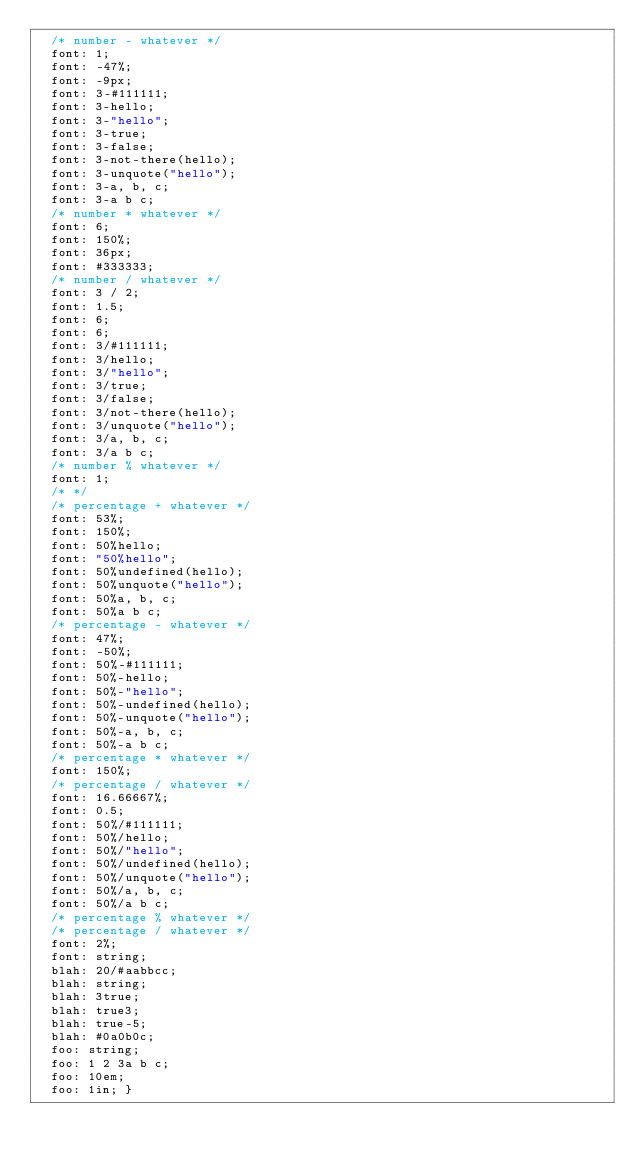Convert code to text. <code><loc_0><loc_0><loc_500><loc_500><_CSS_>  /* number - whatever */
  font: 1;
  font: -47%;
  font: -9px;
  font: 3-#111111;
  font: 3-hello;
  font: 3-"hello";
  font: 3-true;
  font: 3-false;
  font: 3-not-there(hello);
  font: 3-unquote("hello");
  font: 3-a, b, c;
  font: 3-a b c;
  /* number * whatever */
  font: 6;
  font: 150%;
  font: 36px;
  font: #333333;
  /* number / whatever */
  font: 3 / 2;
  font: 1.5;
  font: 6;
  font: 6;
  font: 3/#111111;
  font: 3/hello;
  font: 3/"hello";
  font: 3/true;
  font: 3/false;
  font: 3/not-there(hello);
  font: 3/unquote("hello");
  font: 3/a, b, c;
  font: 3/a b c;
  /* number % whatever */
  font: 1;
  /* */
  /* percentage + whatever */
  font: 53%;
  font: 150%;
  font: 50%hello;
  font: "50%hello";
  font: 50%undefined(hello);
  font: 50%unquote("hello");
  font: 50%a, b, c;
  font: 50%a b c;
  /* percentage - whatever */
  font: 47%;
  font: -50%;
  font: 50%-#111111;
  font: 50%-hello;
  font: 50%-"hello";
  font: 50%-undefined(hello);
  font: 50%-unquote("hello");
  font: 50%-a, b, c;
  font: 50%-a b c;
  /* percentage * whatever */
  font: 150%;
  /* percentage / whatever */
  font: 16.66667%;
  font: 0.5;
  font: 50%/#111111;
  font: 50%/hello;
  font: 50%/"hello";
  font: 50%/undefined(hello);
  font: 50%/unquote("hello");
  font: 50%/a, b, c;
  font: 50%/a b c;
  /* percentage % whatever */
  /* percentage / whatever */
  font: 2%;
  font: string;
  blah: 20/#aabbcc;
  blah: string;
  blah: 3true;
  blah: true3;
  blah: true-5;
  blah: #0a0b0c;
  foo: string;
  foo: 1 2 3a b c;
  foo: 10em;
  foo: 1in; }
</code> 